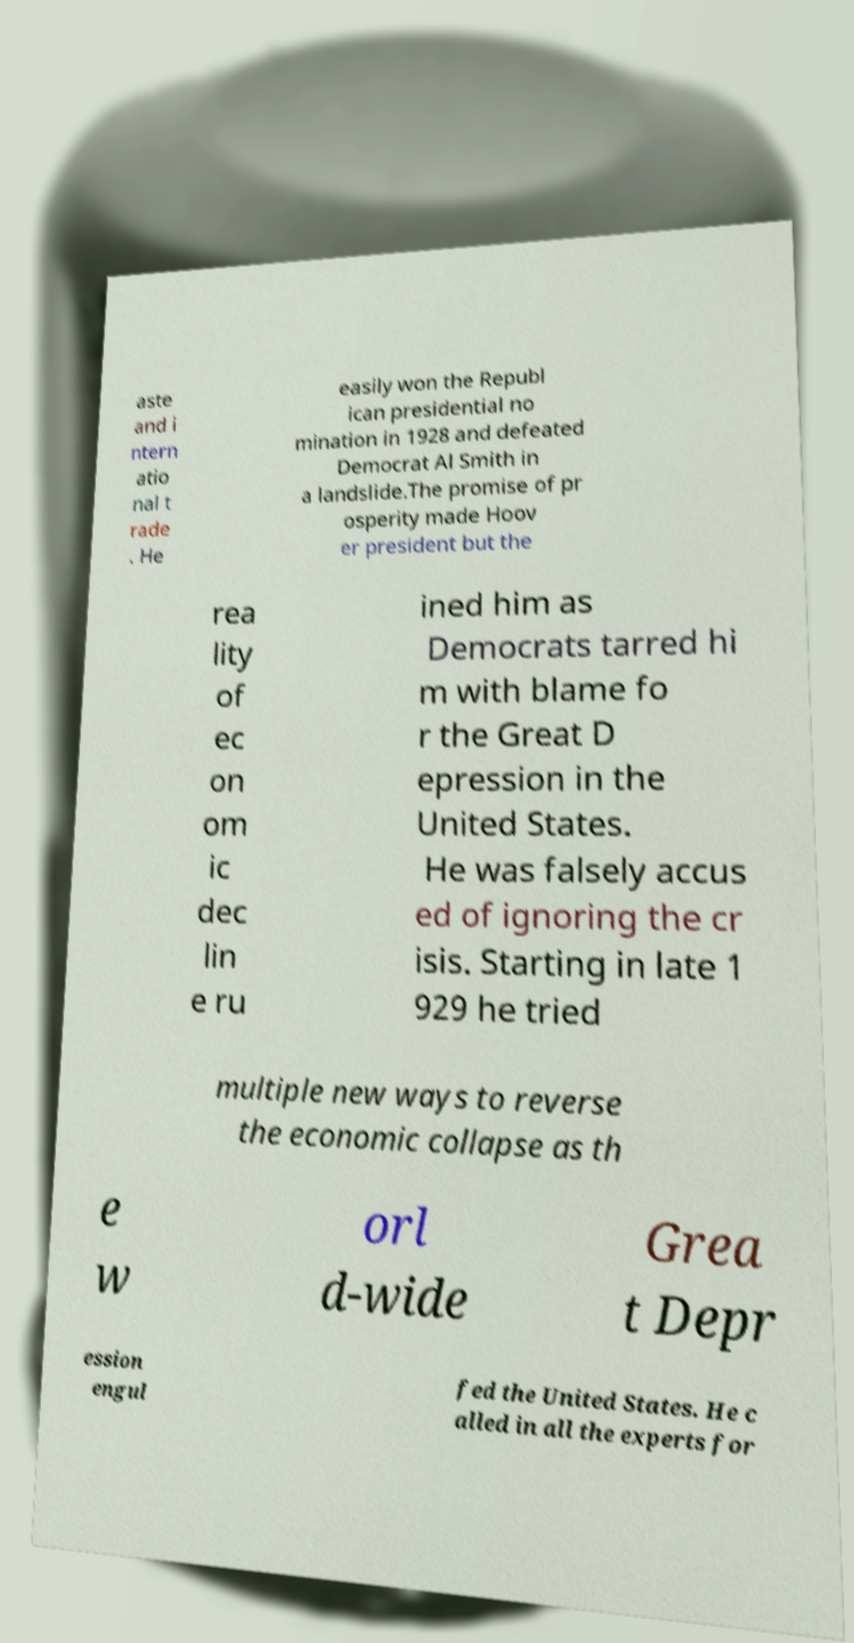I need the written content from this picture converted into text. Can you do that? aste and i ntern atio nal t rade . He easily won the Republ ican presidential no mination in 1928 and defeated Democrat Al Smith in a landslide.The promise of pr osperity made Hoov er president but the rea lity of ec on om ic dec lin e ru ined him as Democrats tarred hi m with blame fo r the Great D epression in the United States. He was falsely accus ed of ignoring the cr isis. Starting in late 1 929 he tried multiple new ways to reverse the economic collapse as th e w orl d-wide Grea t Depr ession engul fed the United States. He c alled in all the experts for 